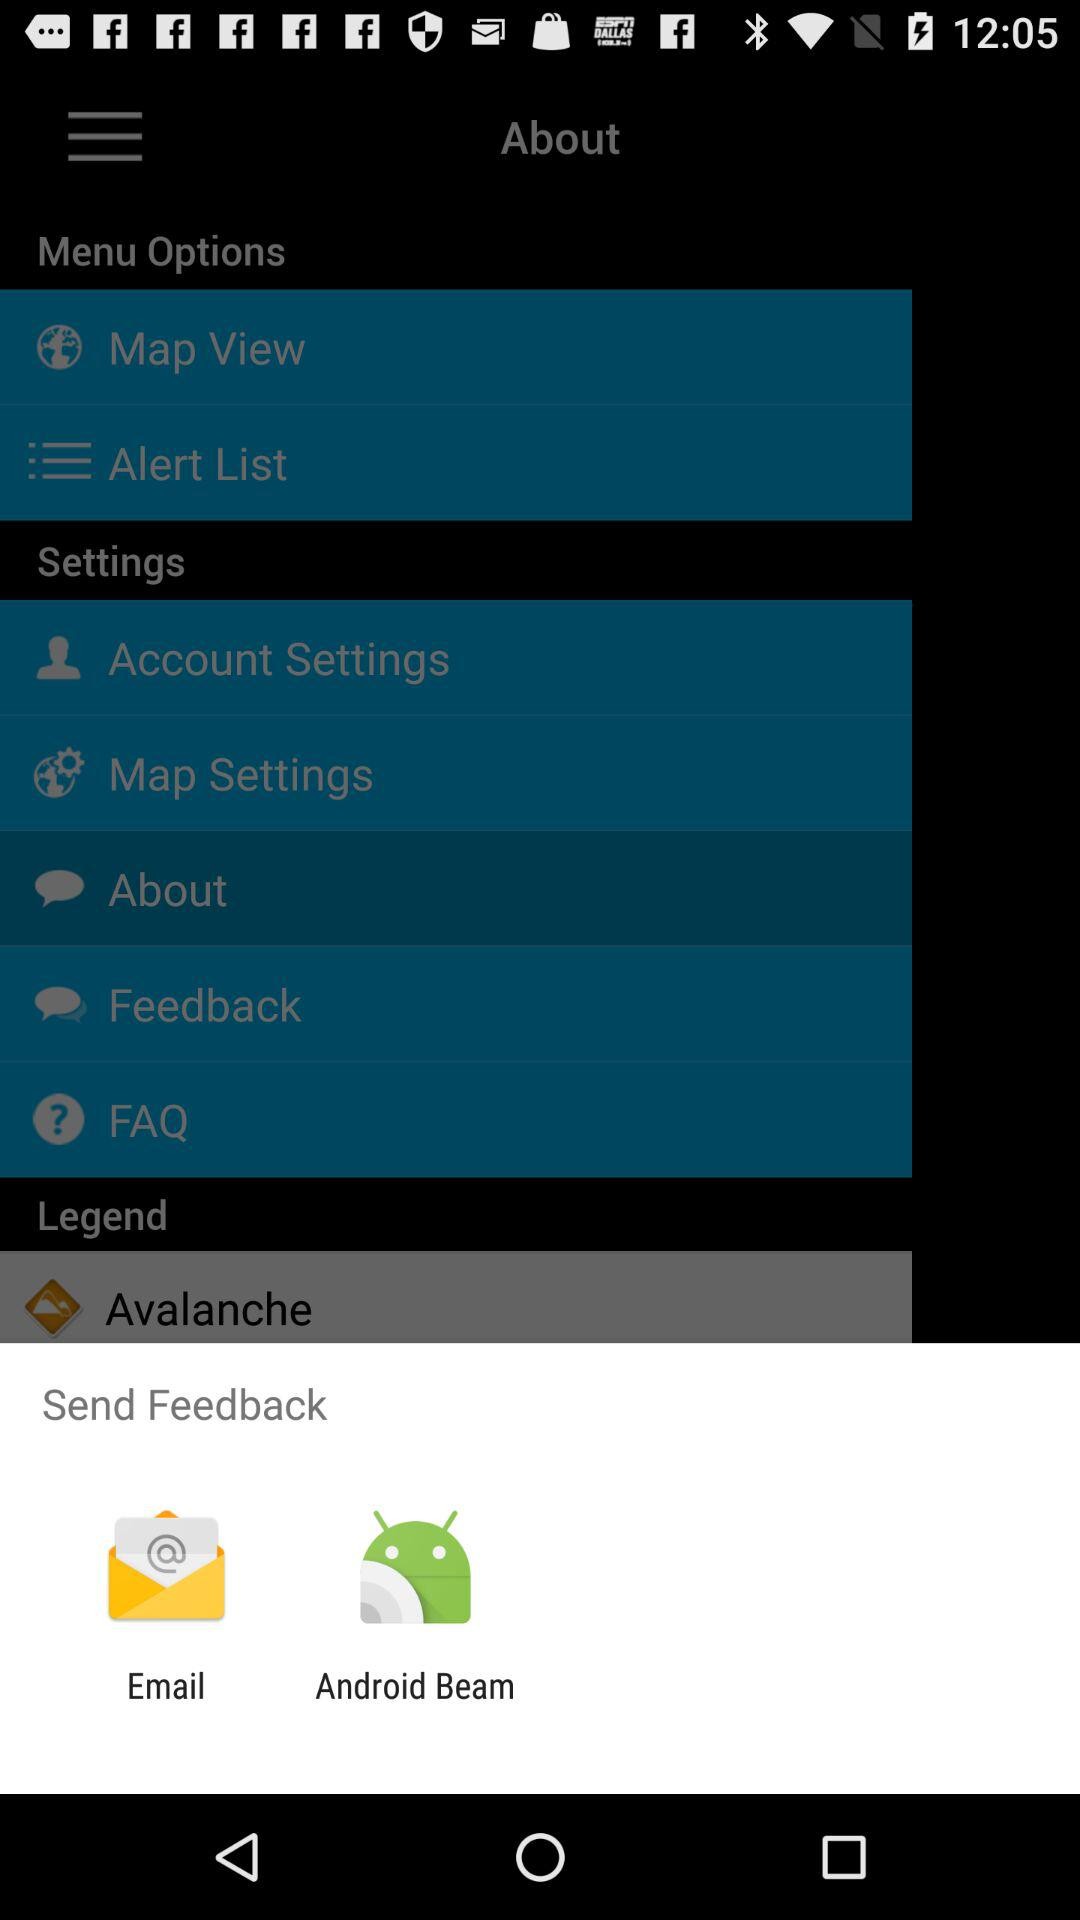Which application can be used to send feedback? The applications "Email" and "Android Beam" can be used to send feedback. 